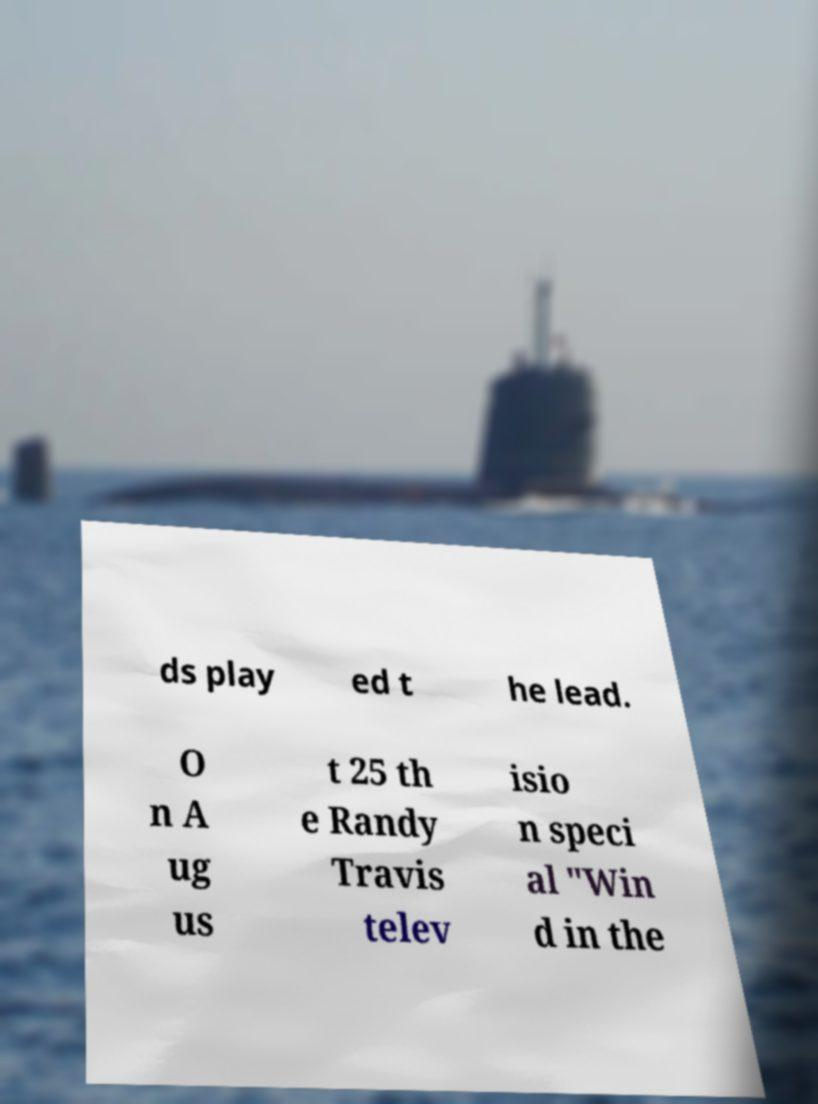For documentation purposes, I need the text within this image transcribed. Could you provide that? ds play ed t he lead. O n A ug us t 25 th e Randy Travis telev isio n speci al "Win d in the 